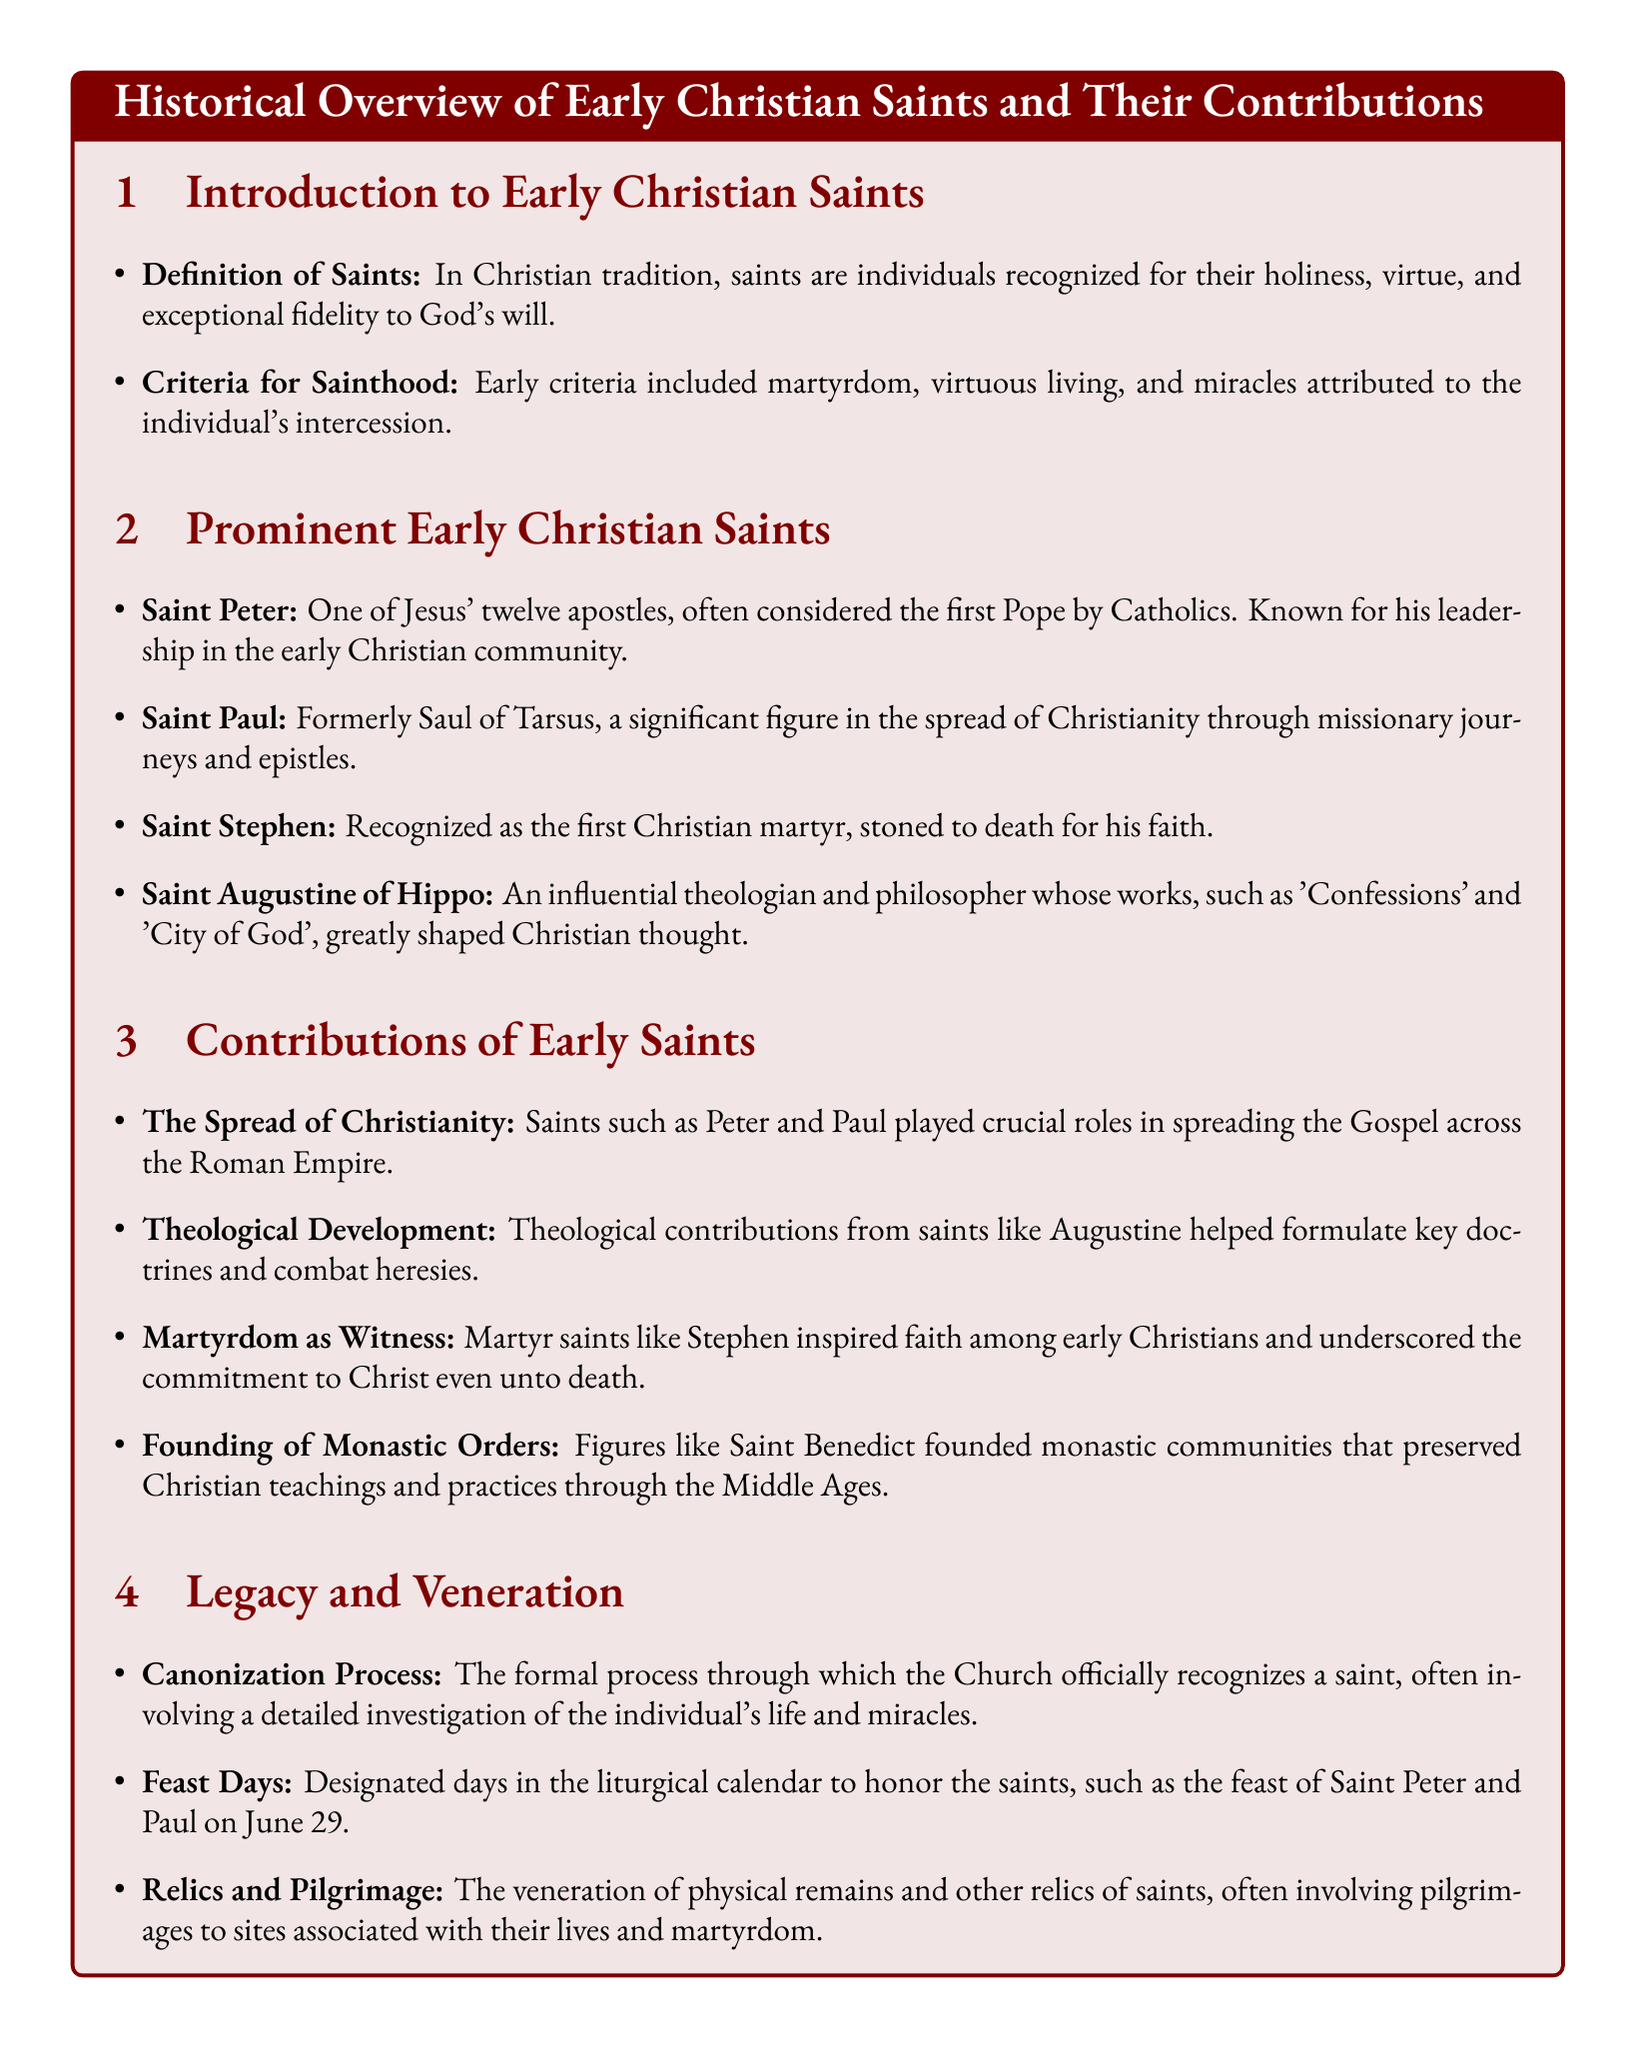What is the definition of saints? The definition of saints is individuals recognized for their holiness, virtue, and exceptional fidelity to God's will.
Answer: Individuals recognized for their holiness, virtue, and exceptional fidelity to God's will Who is considered the first Pope? Saint Peter is known for his leadership in the early Christian community and is considered the first Pope by Catholics.
Answer: Saint Peter What significant role did Saint Paul play? Saint Paul significantly contributed to the spread of Christianity through his missionary journeys and epistles.
Answer: Spread of Christianity Who is recognized as the first Christian martyr? Saint Stephen is recognized as the first Christian martyr, stoned to death for his faith.
Answer: Saint Stephen What key theological contributions did Saint Augustine make? Saint Augustine's works, such as 'Confessions' and 'City of God', greatly shaped Christian thought.
Answer: 'Confessions' and 'City of God' What does martyrdom symbolize? Martyrdom symbolizes a commitment to Christ even unto death and inspires faith among early Christians.
Answer: Commitment to Christ What is the canonization process? The canonization process is the formal process through which the Church officially recognizes a saint.
Answer: Formal process On which date is the feast of Saint Peter and Paul celebrated? The feast of Saint Peter and Paul is celebrated on June 29.
Answer: June 29 What are relics? Relics are the physical remains and other items associated with saints that are venerated.
Answer: Physical remains Which saint founded monastic communities? Saint Benedict founded monastic communities that preserved Christian teachings and practices.
Answer: Saint Benedict 